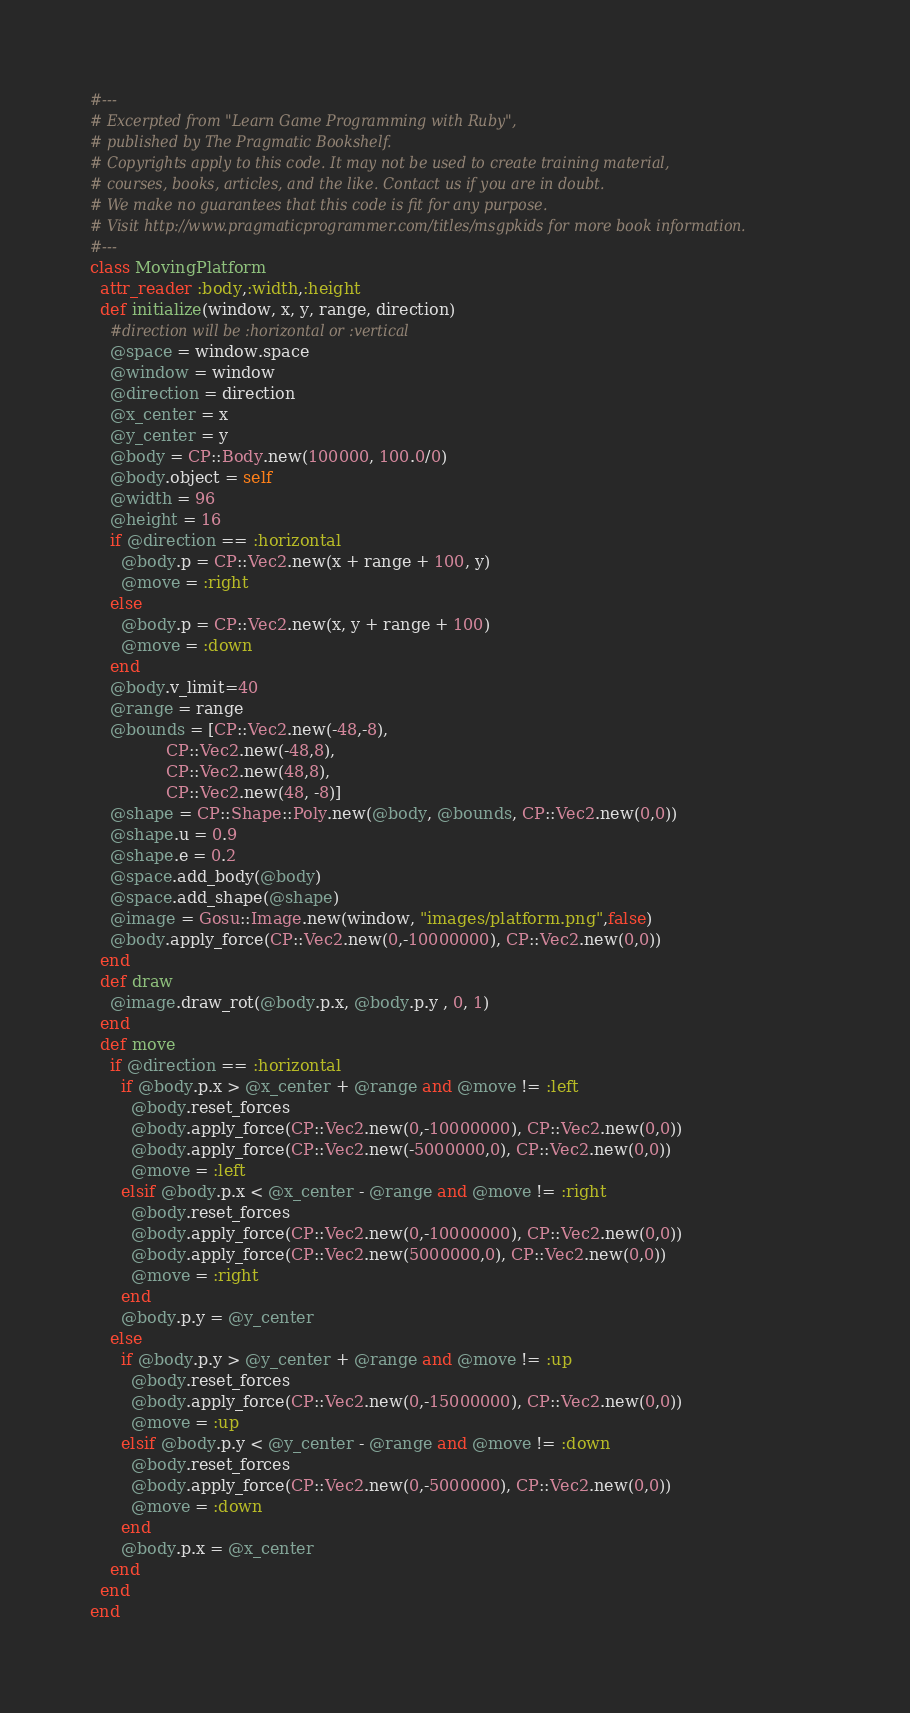Convert code to text. <code><loc_0><loc_0><loc_500><loc_500><_Ruby_>#---
# Excerpted from "Learn Game Programming with Ruby",
# published by The Pragmatic Bookshelf.
# Copyrights apply to this code. It may not be used to create training material, 
# courses, books, articles, and the like. Contact us if you are in doubt.
# We make no guarantees that this code is fit for any purpose. 
# Visit http://www.pragmaticprogrammer.com/titles/msgpkids for more book information.
#---
class MovingPlatform
  attr_reader :body,:width,:height
  def initialize(window, x, y, range, direction)
    #direction will be :horizontal or :vertical
    @space = window.space
    @window = window
    @direction = direction
    @x_center = x
    @y_center = y
    @body = CP::Body.new(100000, 100.0/0)
    @body.object = self
    @width = 96
    @height = 16
    if @direction == :horizontal
      @body.p = CP::Vec2.new(x + range + 100, y)
      @move = :right
    else
      @body.p = CP::Vec2.new(x, y + range + 100)
      @move = :down
    end
    @body.v_limit=40
    @range = range
    @bounds = [CP::Vec2.new(-48,-8), 
               CP::Vec2.new(-48,8), 
               CP::Vec2.new(48,8), 
               CP::Vec2.new(48, -8)]
    @shape = CP::Shape::Poly.new(@body, @bounds, CP::Vec2.new(0,0))
    @shape.u = 0.9
    @shape.e = 0.2
    @space.add_body(@body)
    @space.add_shape(@shape)
    @image = Gosu::Image.new(window, "images/platform.png",false)
    @body.apply_force(CP::Vec2.new(0,-10000000), CP::Vec2.new(0,0))
  end
  def draw
    @image.draw_rot(@body.p.x, @body.p.y , 0, 1)
  end
  def move
    if @direction == :horizontal
      if @body.p.x > @x_center + @range and @move != :left
        @body.reset_forces
        @body.apply_force(CP::Vec2.new(0,-10000000), CP::Vec2.new(0,0))
        @body.apply_force(CP::Vec2.new(-5000000,0), CP::Vec2.new(0,0))
        @move = :left
      elsif @body.p.x < @x_center - @range and @move != :right
        @body.reset_forces
        @body.apply_force(CP::Vec2.new(0,-10000000), CP::Vec2.new(0,0))
        @body.apply_force(CP::Vec2.new(5000000,0), CP::Vec2.new(0,0))
        @move = :right
      end
      @body.p.y = @y_center
    else
      if @body.p.y > @y_center + @range and @move != :up
        @body.reset_forces
        @body.apply_force(CP::Vec2.new(0,-15000000), CP::Vec2.new(0,0))
        @move = :up
      elsif @body.p.y < @y_center - @range and @move != :down
        @body.reset_forces
        @body.apply_force(CP::Vec2.new(0,-5000000), CP::Vec2.new(0,0))
        @move = :down
      end
      @body.p.x = @x_center
    end
  end
end
</code> 